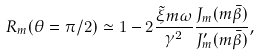Convert formula to latex. <formula><loc_0><loc_0><loc_500><loc_500>R _ { m } ( \theta = \pi / 2 ) \simeq 1 - 2 \frac { { \tilde { \xi } } m \omega } { \gamma ^ { 2 } } \frac { J _ { m } ( m \bar { \beta } ) } { J _ { m } ^ { \prime } ( m \bar { \beta } ) } ,</formula> 